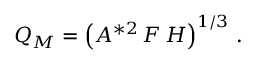Convert formula to latex. <formula><loc_0><loc_0><loc_500><loc_500>Q _ { M } = \left ( A ^ { * 2 } \, F \, H \right ) ^ { 1 / 3 } \, .</formula> 